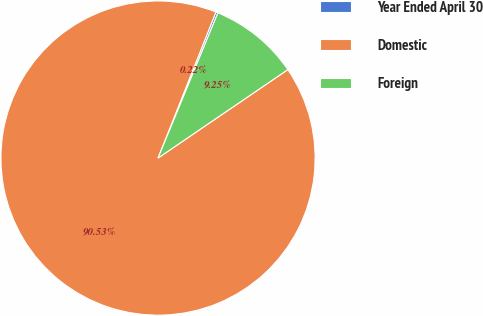<chart> <loc_0><loc_0><loc_500><loc_500><pie_chart><fcel>Year Ended April 30<fcel>Domestic<fcel>Foreign<nl><fcel>0.22%<fcel>90.52%<fcel>9.25%<nl></chart> 